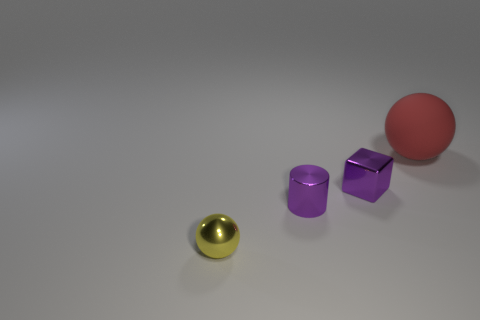Do the small shiny cube and the cylinder have the same color?
Provide a short and direct response. Yes. What material is the tiny cube that is the same color as the shiny cylinder?
Provide a short and direct response. Metal. What is the material of the yellow object?
Your answer should be very brief. Metal. Does the sphere that is behind the small yellow metallic object have the same material as the purple cube?
Make the answer very short. No. What is the shape of the shiny object that is in front of the tiny cylinder?
Your answer should be very brief. Sphere. There is a block that is the same size as the yellow thing; what material is it?
Offer a terse response. Metal. How many things are metallic things that are on the right side of the yellow metallic ball or spheres that are behind the tiny metal cube?
Keep it short and to the point. 3. What is the size of the purple block that is made of the same material as the yellow sphere?
Offer a terse response. Small. How many rubber objects are yellow balls or tiny blue cubes?
Ensure brevity in your answer.  0. What size is the red matte sphere?
Your response must be concise. Large. 